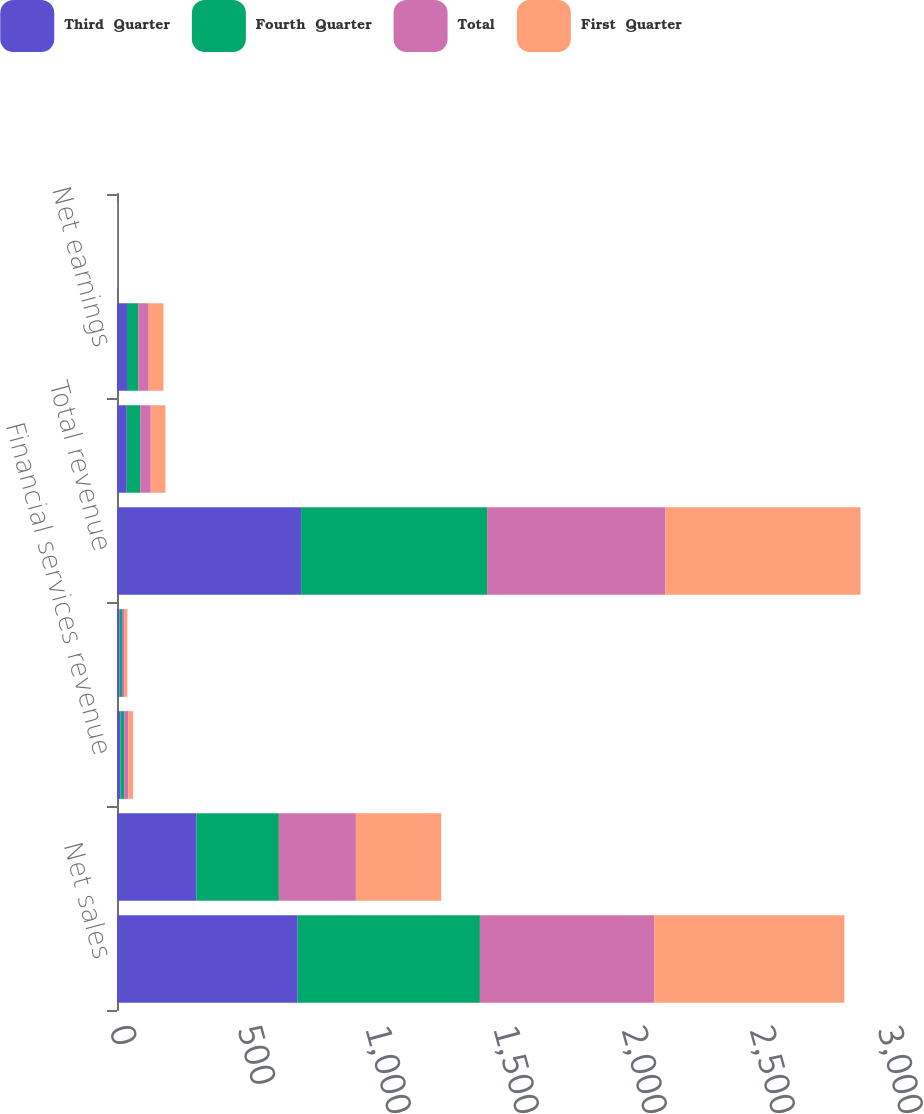Convert chart to OTSL. <chart><loc_0><loc_0><loc_500><loc_500><stacked_bar_chart><ecel><fcel>Net sales<fcel>Gross profit<fcel>Financial services revenue<fcel>Financial services expenses<fcel>Total revenue<fcel>Net earnings from continuing<fcel>Net earnings<fcel>Earnings per share - basic<nl><fcel>Third  Quarter<fcel>705.7<fcel>309.9<fcel>13.4<fcel>9.7<fcel>719.1<fcel>38<fcel>39<fcel>0.67<nl><fcel>Fourth  Quarter<fcel>711.9<fcel>322.4<fcel>14.8<fcel>9.7<fcel>726.7<fcel>52.8<fcel>43.8<fcel>0.75<nl><fcel>Total<fcel>680.7<fcel>300.9<fcel>15.8<fcel>10.2<fcel>696.5<fcel>41.1<fcel>41.1<fcel>0.71<nl><fcel>First  Quarter<fcel>742.9<fcel>333.4<fcel>19<fcel>11<fcel>761.9<fcel>57.3<fcel>57.3<fcel>1<nl></chart> 